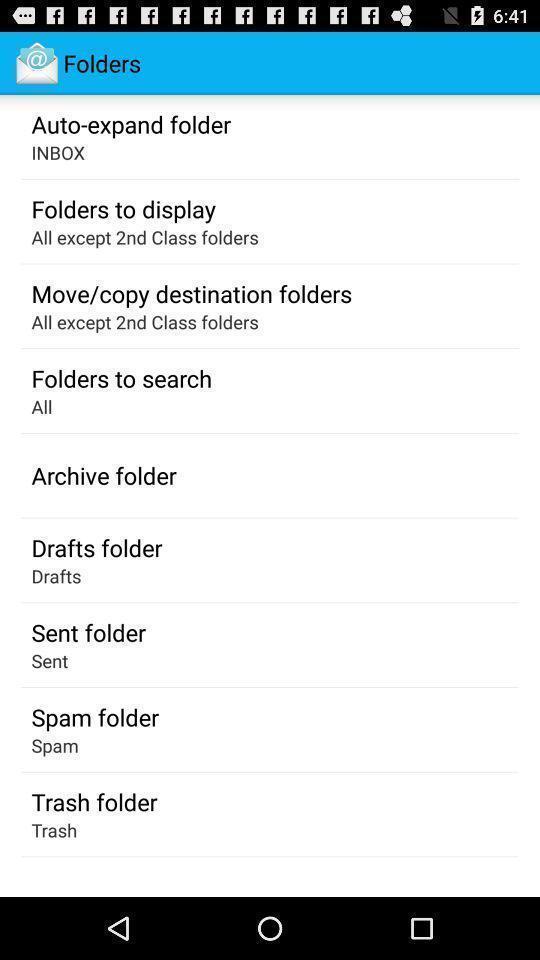Give me a narrative description of this picture. Various folders options displayed. 